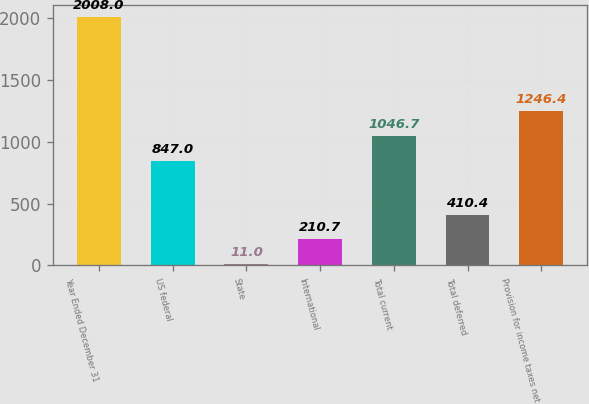Convert chart to OTSL. <chart><loc_0><loc_0><loc_500><loc_500><bar_chart><fcel>Year Ended December 31<fcel>US federal<fcel>State<fcel>International<fcel>Total current<fcel>Total deferred<fcel>Provision for income taxes net<nl><fcel>2008<fcel>847<fcel>11<fcel>210.7<fcel>1046.7<fcel>410.4<fcel>1246.4<nl></chart> 